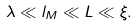<formula> <loc_0><loc_0><loc_500><loc_500>\lambda \ll l _ { M } \ll L \ll \xi .</formula> 